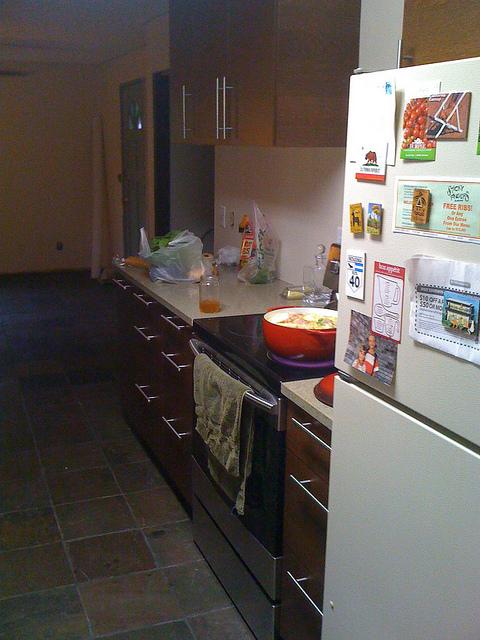Do you see a pot with a lid?
Be succinct. Yes. Is anyone in the kitchen?
Short answer required. No. Is this in an office?
Concise answer only. No. What room is this?
Write a very short answer. Kitchen. Is this the bathroom?
Concise answer only. No. 